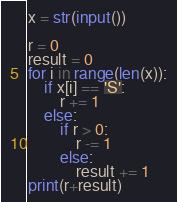<code> <loc_0><loc_0><loc_500><loc_500><_Python_>x = str(input())

r = 0
result = 0
for i in range(len(x)):
    if x[i] == 'S':
        r += 1
    else:
        if r > 0:
            r -= 1
        else:
            result += 1
print(r+result)</code> 